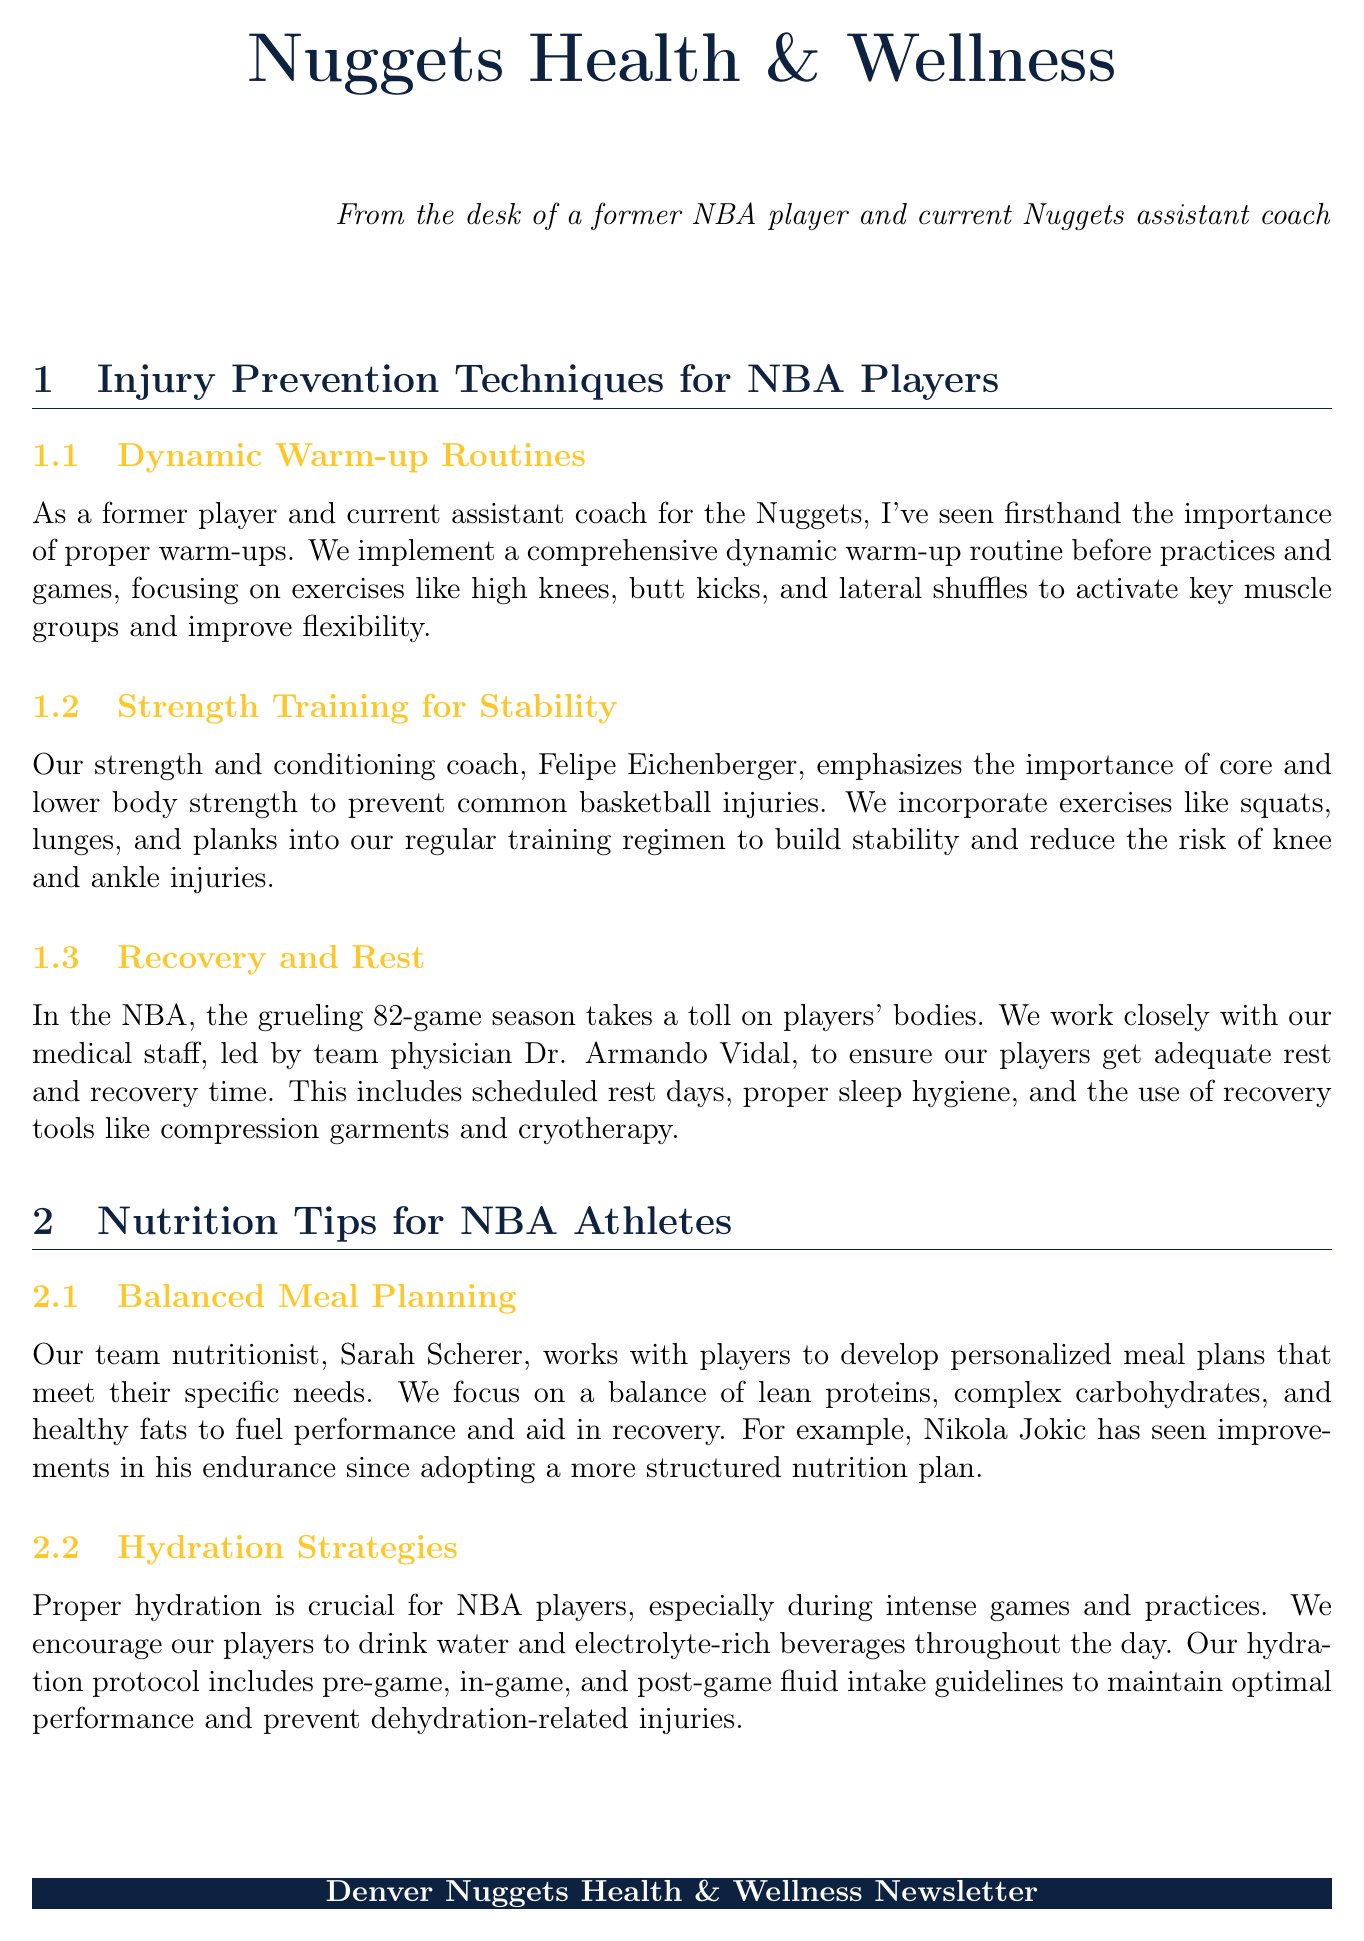What is the title of the first section? The title of the first section focuses on injury prevention techniques aimed at NBA players.
Answer: Injury Prevention Techniques for NBA Players Who is the team nutritionist mentioned in the newsletter? The newsletter specifies the name of the team nutritionist who develops meal plans for players.
Answer: Sarah Scherer What exercises are included in the strength training for stability? The document lists exercises that build core and lower body strength to prevent basketball injuries.
Answer: Squats, lunges, and planks What is emphasized as important for hydration strategies? The newsletter highlights the significance of maintaining fluid intake throughout various phases of a game.
Answer: Proper hydration How does the team support players' recovery and rest? The document outlines approaches taken by the medical staff regarding rest and recovery to support players.
Answer: Scheduled rest days Which sports psychologist works with the team? The newsletter identifies the sports psychologist who provides stress management tools to the players.
Answer: Dr. Michelle Garvin What type of supplement is recommended for joint health? The document mentions specific supplements recommended under the guidance of the medical staff for player health.
Answer: Omega-3 fatty acids What is one recovery tool used by the team? The newsletter lists tools employed by the team for player recovery and wellness during the season.
Answer: Compression garments 